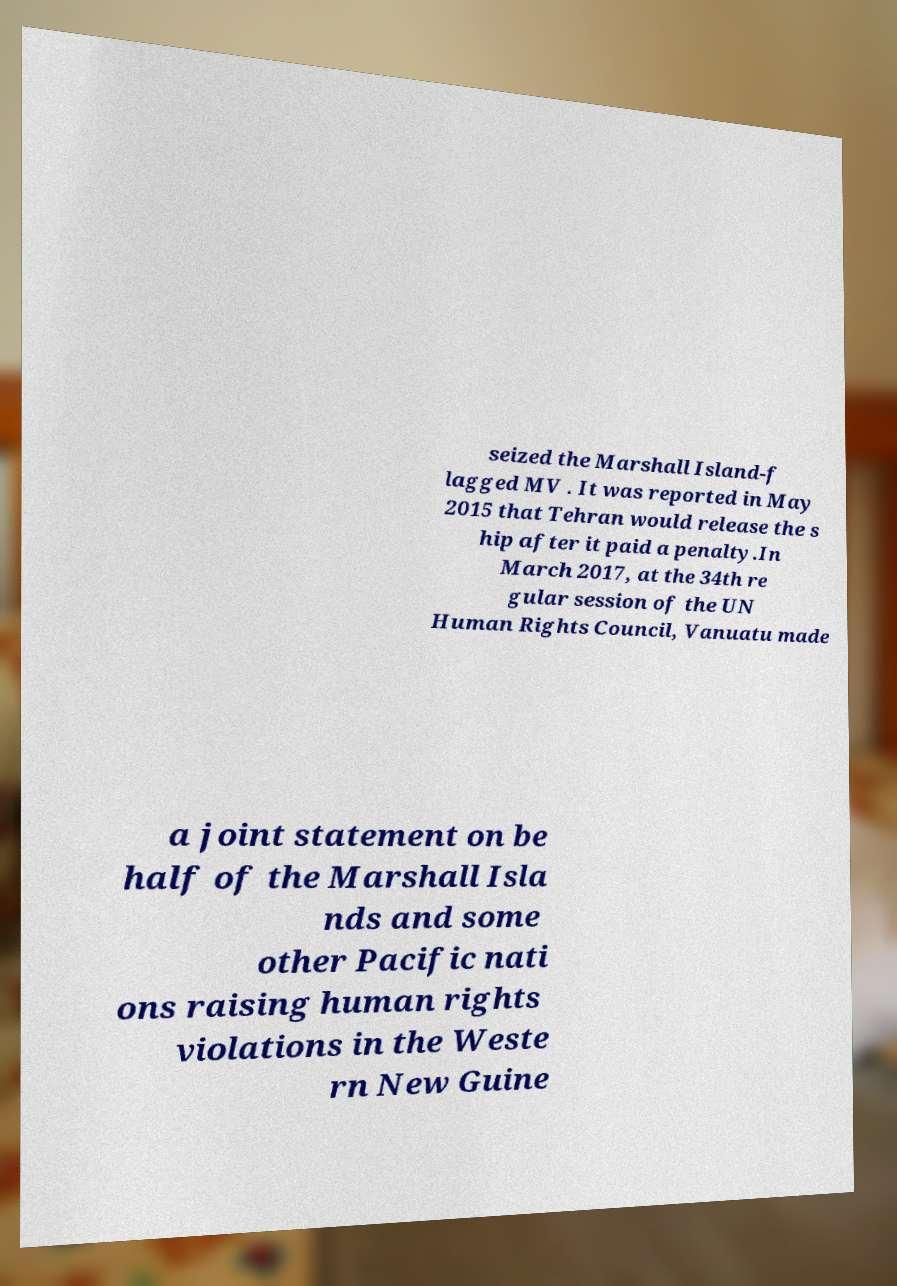Can you accurately transcribe the text from the provided image for me? seized the Marshall Island-f lagged MV . It was reported in May 2015 that Tehran would release the s hip after it paid a penalty.In March 2017, at the 34th re gular session of the UN Human Rights Council, Vanuatu made a joint statement on be half of the Marshall Isla nds and some other Pacific nati ons raising human rights violations in the Weste rn New Guine 